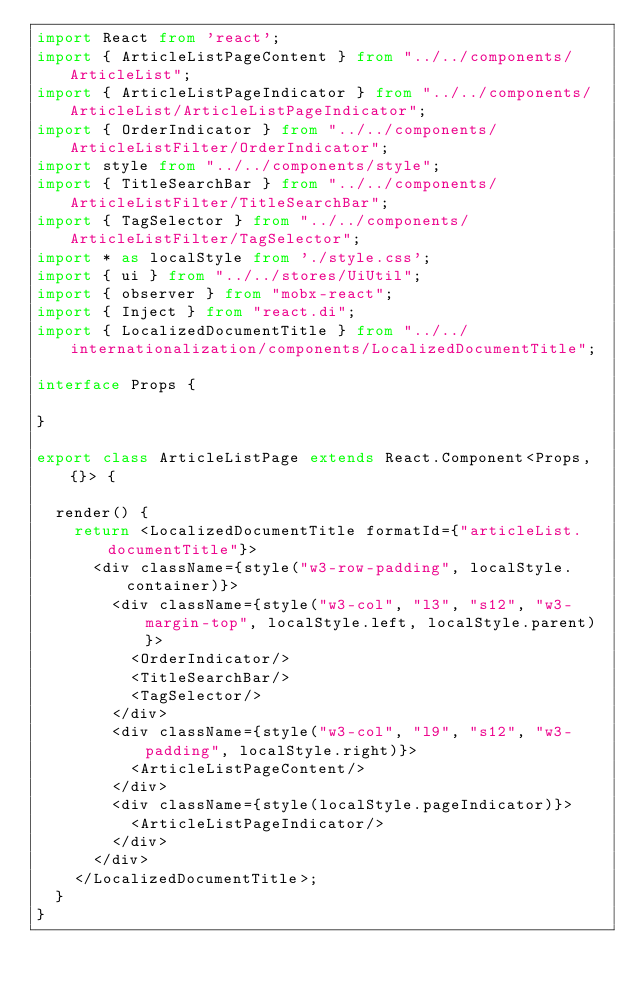Convert code to text. <code><loc_0><loc_0><loc_500><loc_500><_TypeScript_>import React from 'react';
import { ArticleListPageContent } from "../../components/ArticleList";
import { ArticleListPageIndicator } from "../../components/ArticleList/ArticleListPageIndicator";
import { OrderIndicator } from "../../components/ArticleListFilter/OrderIndicator";
import style from "../../components/style";
import { TitleSearchBar } from "../../components/ArticleListFilter/TitleSearchBar";
import { TagSelector } from "../../components/ArticleListFilter/TagSelector";
import * as localStyle from './style.css';
import { ui } from "../../stores/UiUtil";
import { observer } from "mobx-react";
import { Inject } from "react.di";
import { LocalizedDocumentTitle } from "../../internationalization/components/LocalizedDocumentTitle";

interface Props {

}

export class ArticleListPage extends React.Component<Props, {}> {

  render() {
    return <LocalizedDocumentTitle formatId={"articleList.documentTitle"}>
      <div className={style("w3-row-padding", localStyle.container)}>
        <div className={style("w3-col", "l3", "s12", "w3-margin-top", localStyle.left, localStyle.parent)}>
          <OrderIndicator/>
          <TitleSearchBar/>
          <TagSelector/>
        </div>
        <div className={style("w3-col", "l9", "s12", "w3-padding", localStyle.right)}>
          <ArticleListPageContent/>
        </div>
        <div className={style(localStyle.pageIndicator)}>
          <ArticleListPageIndicator/>
        </div>
      </div>
    </LocalizedDocumentTitle>;
  }
}
</code> 